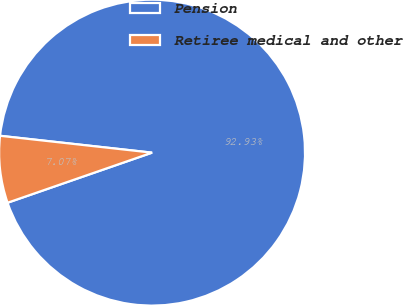<chart> <loc_0><loc_0><loc_500><loc_500><pie_chart><fcel>Pension<fcel>Retiree medical and other<nl><fcel>92.93%<fcel>7.07%<nl></chart> 